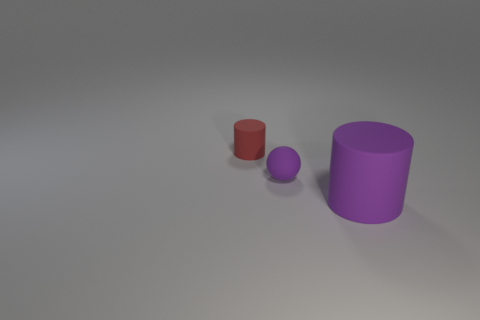Is there anything else that is the same size as the purple cylinder?
Make the answer very short. No. Is the rubber sphere the same size as the red matte cylinder?
Offer a terse response. Yes. Is there a small cyan rubber thing?
Provide a succinct answer. No. There is a rubber thing that is the same color as the small ball; what is its size?
Your response must be concise. Large. How big is the purple object that is in front of the tiny rubber object in front of the cylinder behind the large thing?
Offer a very short reply. Large. What number of small yellow blocks have the same material as the small cylinder?
Provide a succinct answer. 0. How many red objects are the same size as the purple ball?
Provide a short and direct response. 1. There is a purple object behind the cylinder that is in front of the purple thing behind the big purple rubber object; what is it made of?
Offer a terse response. Rubber. How many things are rubber cylinders or large brown rubber cubes?
Your response must be concise. 2. Are there any other things that have the same material as the tiny purple sphere?
Keep it short and to the point. Yes. 